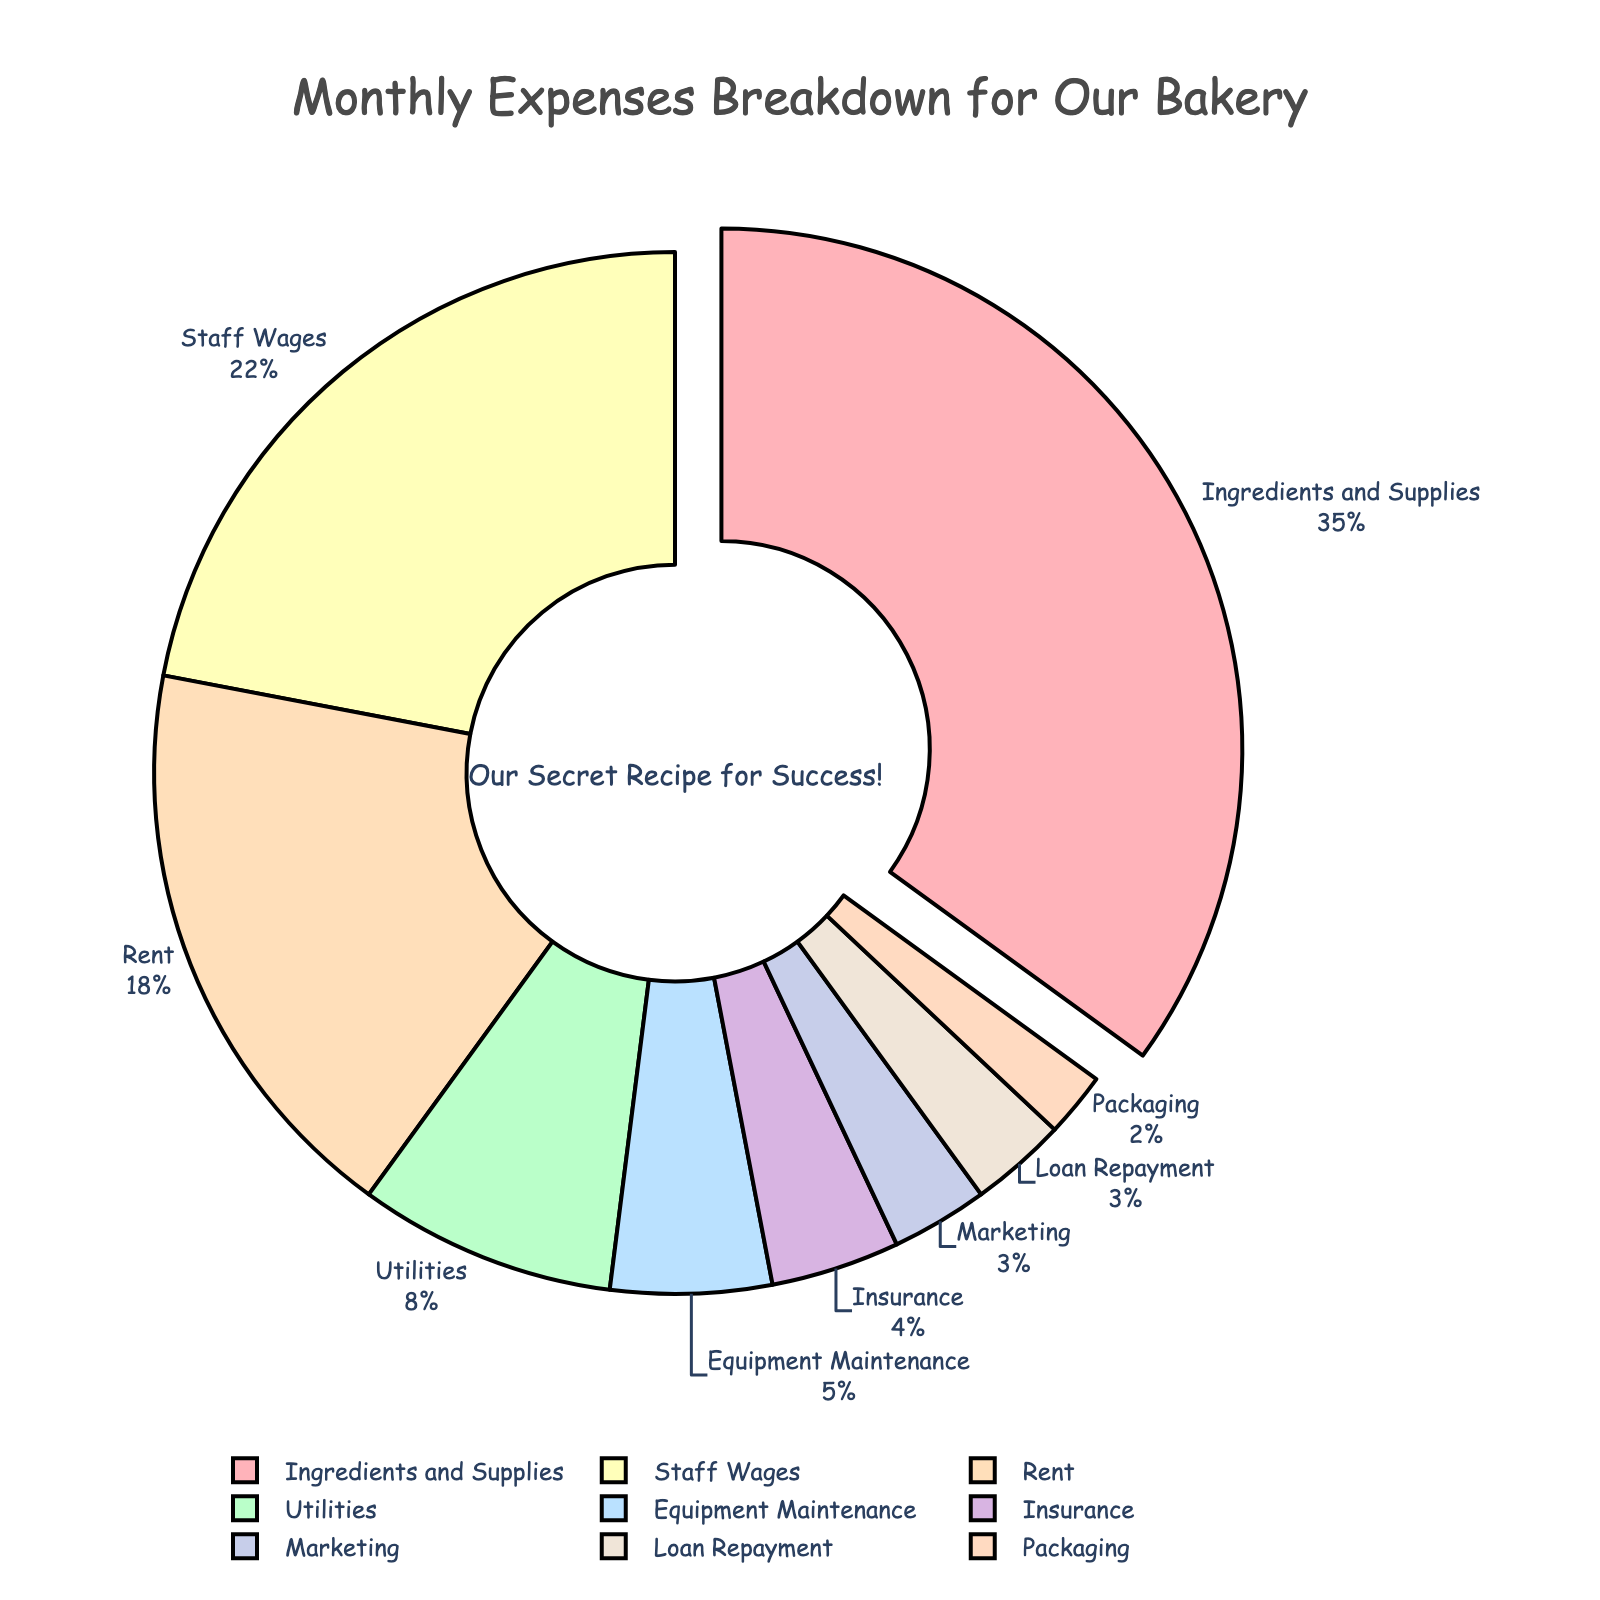What percentage of the monthly expenses is allocated to Ingredients and Supplies? Ingredients and Supplies is allocated 35% as shown on the pie chart.
Answer: 35% Which category has the second largest allocation of monthly expenses? By observing the proportions on the pie chart, Staff Wages has the second largest allocation, which is 22%.
Answer: Staff Wages What is the total percentage allocation for Rent and Utilities combined? Rent is 18% and Utilities is 8%. Adding them together gives 18% + 8% = 26%.
Answer: 26% Which category has the lowest allocation of monthly expenses? Packaging has the lowest allocation at 2%, as observed in the pie chart.
Answer: Packaging What is the combined percentage for categories with allocations below 10%? The categories below 10% are: Utilities (8%), Equipment Maintenance (5%), Marketing (3%), Insurance (4%), Loan Repayment (3%), and Packaging (2%). Adding them together gives 8% + 5% + 3% + 4% + 3% + 2% = 25%.
Answer: 25% How does the allocation for Staff Wages compare to that for Rent? Staff Wages is allocated 22%, while Rent is allocated 18%. Staff Wages is greater by 22% - 18% = 4%.
Answer: 4% What can be inferred from the color used for the largest segment? The largest segment, representing Ingredients and Supplies at 35%, is highlighted by being slightly pulled out from the rest of the pie chart. Its color is one of the distinguishing colors in the chart.
Answer: Distinguishing color and pulled-out segment If you combine the percentages for Equipment Maintenance, Marketing, Insurance, and Loan Repayment, do they surpass the percentage allocated to Rent? Equipment Maintenance is 5%, Marketing is 3%, Insurance is 4%, and Loan Repayment is 3%. Summing these gives 5% + 3% + 4% + 3% = 15%, which is less than Rent's 18%.
Answer: No What is the visual distinction used for the segment with the largest percentage? The segment for Ingredients and Supplies is slightly pulled out from the pie chart to visually highlight it.
Answer: Pulled out What is the smallest percentage allocation that is still greater than the allocation for Packaging? Loan Repayment is allocated 3%, which is the smallest percentage greater than Packaging’s 2%.
Answer: Loan Repayment What percentage of the monthly expenses is allocated to categories related to operations (Ingredients and Supplies, Staff Wages, Equipment Maintenance, and Packaging)? The percentages for related categories are: Ingredients and Supplies (35%), Staff Wages (22%), Equipment Maintenance (5%), and Packaging (2%). Summing these gives 35% + 22% + 5% + 2% = 64%.
Answer: 64% 